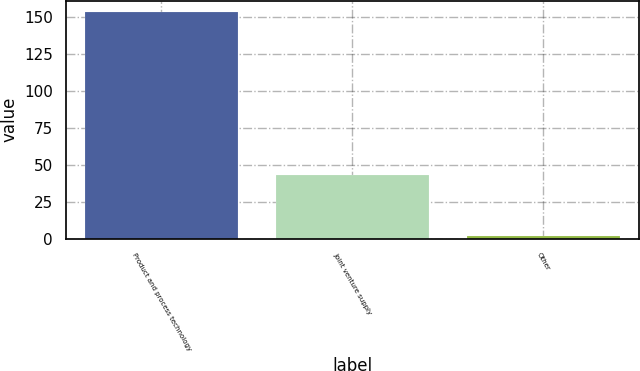<chart> <loc_0><loc_0><loc_500><loc_500><bar_chart><fcel>Product and process technology<fcel>Joint venture supply<fcel>Other<nl><fcel>153.6<fcel>43<fcel>1.7<nl></chart> 